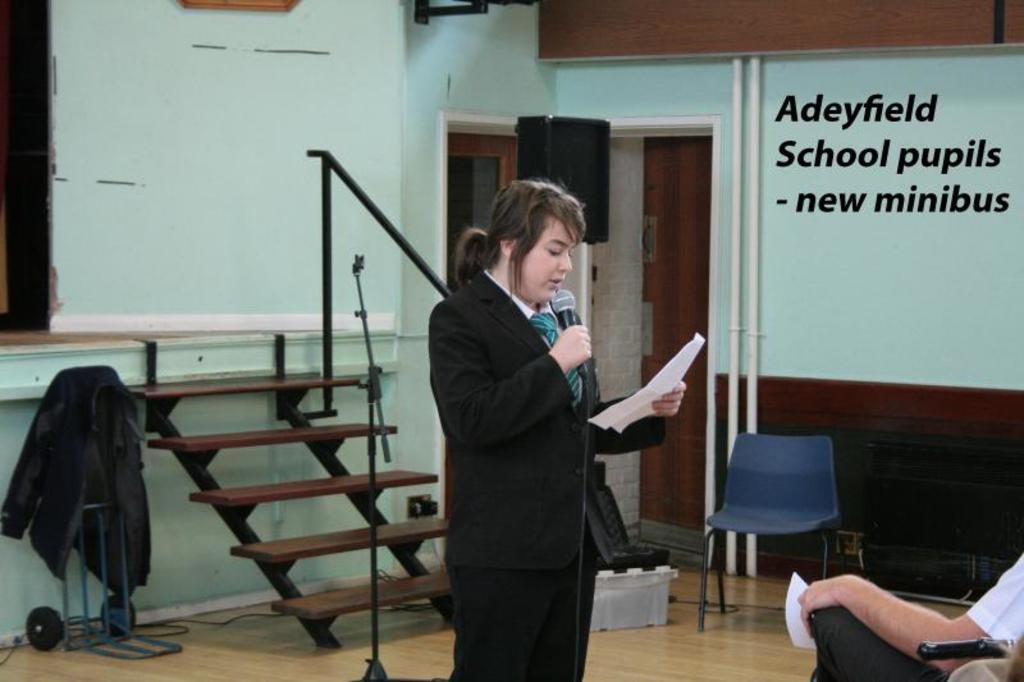How would you summarize this image in a sentence or two? In this image a lady wearing black suit is talking something. She is holding a mic and paper. in front of her people are sitting. In the background coat,staircase, stand, speaker and wall is there. 